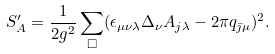Convert formula to latex. <formula><loc_0><loc_0><loc_500><loc_500>S ^ { \prime } _ { A } = \frac { 1 } { 2 g ^ { 2 } } \sum _ { \Box } ( \epsilon _ { \mu \nu \lambda } \Delta _ { \nu } A _ { j \lambda } - 2 \pi q _ { \bar { \jmath } \mu } ) ^ { 2 } .</formula> 